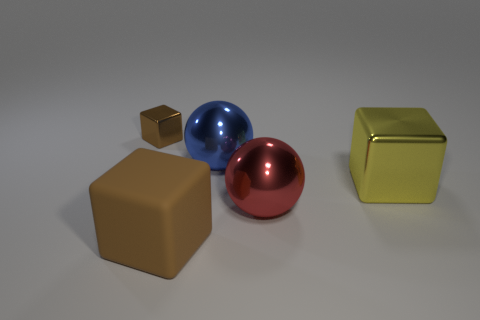What shape is the big matte object that is the same color as the small metallic object?
Give a very brief answer. Cube. There is a small cube that is the same color as the big rubber cube; what material is it?
Your response must be concise. Metal. Do the small metal object and the rubber thing have the same color?
Provide a succinct answer. Yes. How many big objects are green metal cylinders or yellow things?
Your response must be concise. 1. How many other objects are the same color as the large rubber thing?
Make the answer very short. 1. How many brown things are made of the same material as the yellow block?
Your answer should be compact. 1. There is a cube on the left side of the brown rubber cube; is it the same color as the matte thing?
Provide a short and direct response. Yes. What number of brown objects are small objects or tiny metal balls?
Give a very brief answer. 1. Is there anything else that has the same material as the large brown block?
Give a very brief answer. No. Is the material of the block that is to the right of the large red metal sphere the same as the big brown thing?
Your answer should be very brief. No. 